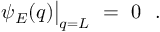Convert formula to latex. <formula><loc_0><loc_0><loc_500><loc_500>\psi _ { E } ( q ) \Big | _ { q = L } \ = \ 0 \ \ .</formula> 